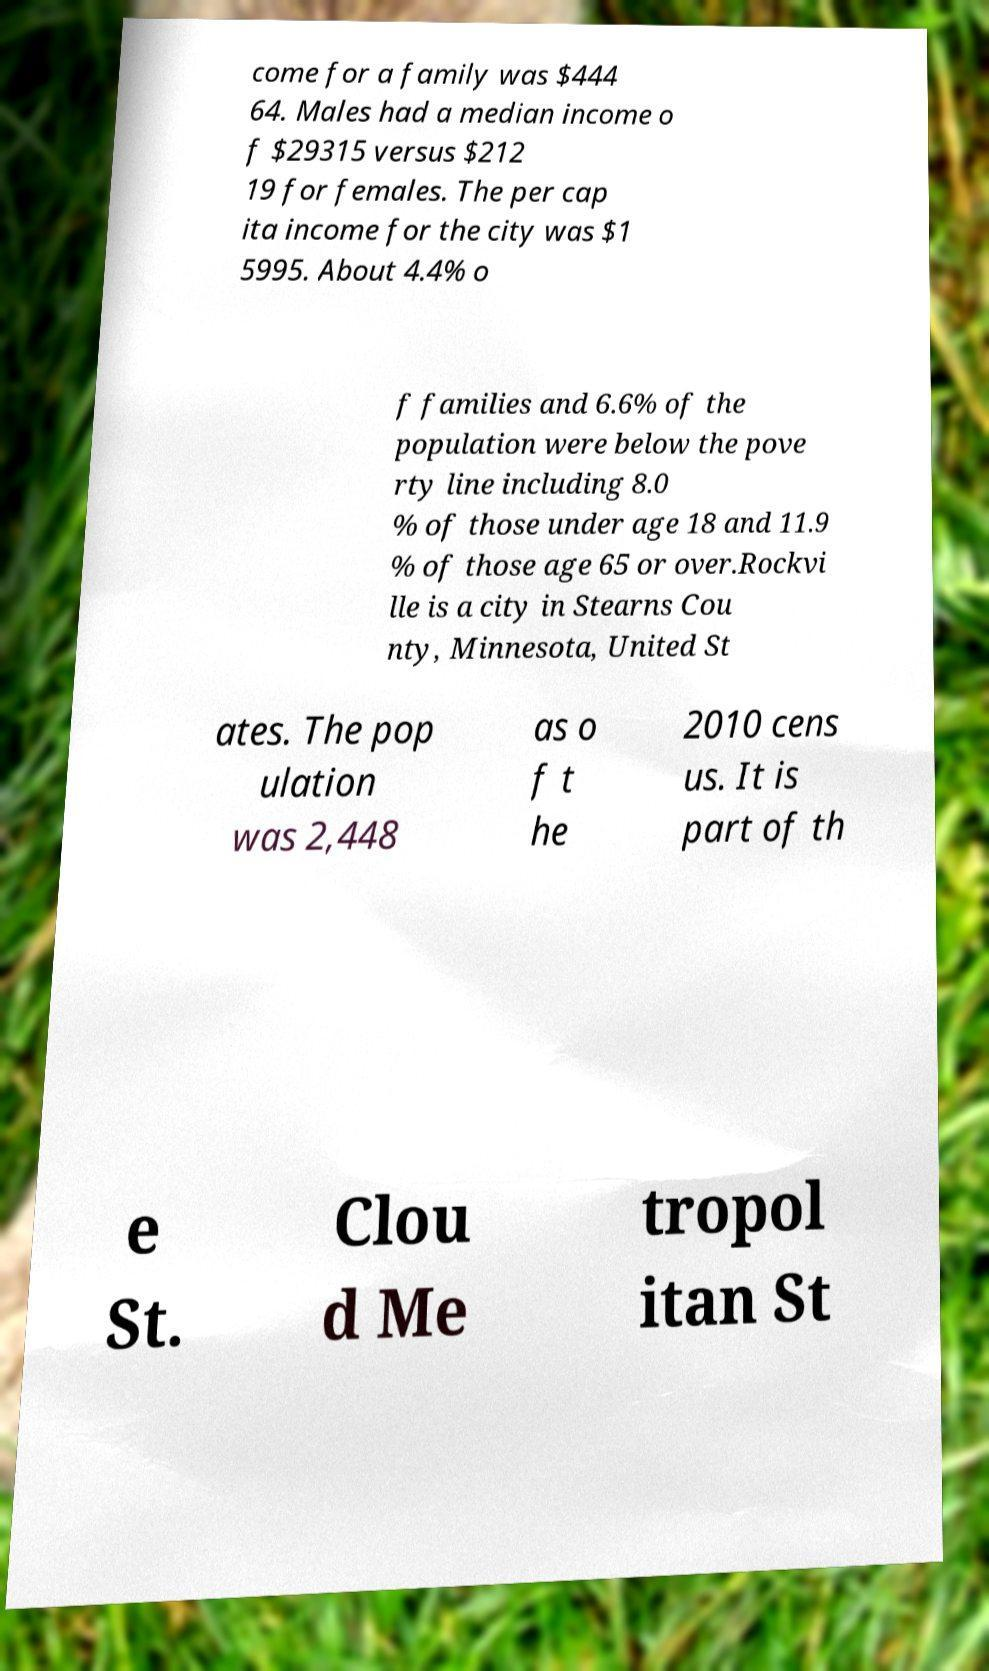What messages or text are displayed in this image? I need them in a readable, typed format. come for a family was $444 64. Males had a median income o f $29315 versus $212 19 for females. The per cap ita income for the city was $1 5995. About 4.4% o f families and 6.6% of the population were below the pove rty line including 8.0 % of those under age 18 and 11.9 % of those age 65 or over.Rockvi lle is a city in Stearns Cou nty, Minnesota, United St ates. The pop ulation was 2,448 as o f t he 2010 cens us. It is part of th e St. Clou d Me tropol itan St 